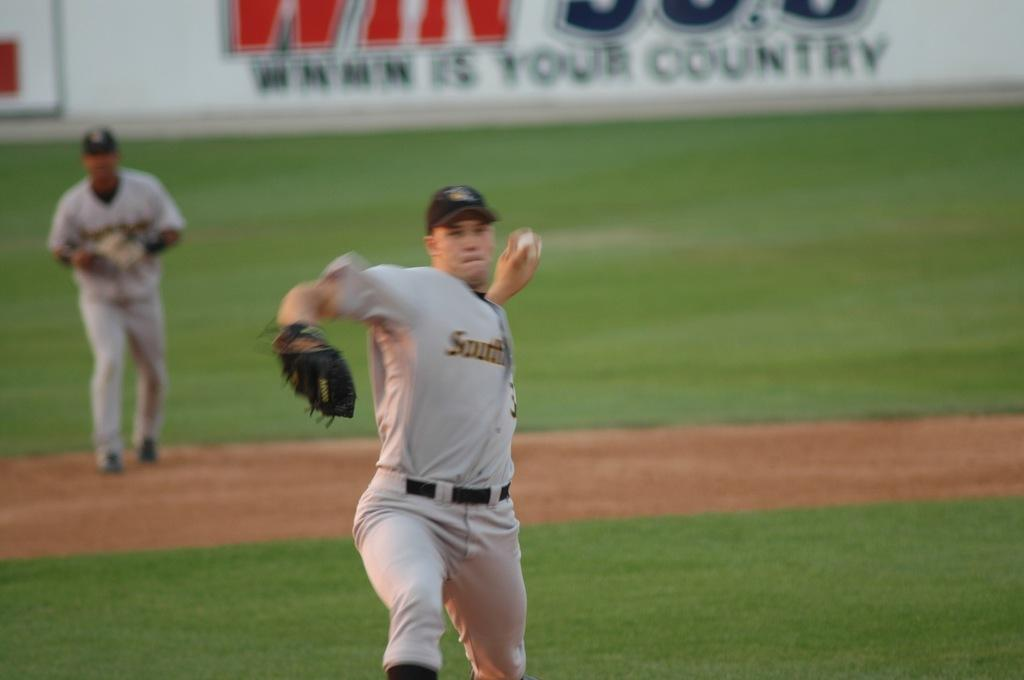How many people are in the image? There are two persons in the image. What are the two persons doing in the image? The two persons are playing baseball. What action is one of the persons taking in the image? One person is throwing a ball. What additional object can be seen in the image? There is a board with text in the image. How many spiders are crawling on the baseball bat in the image? There are no spiders present in the image. What role does the father play in the baseball game in the image? The provided facts do not mention a father or any familial relationships, so we cannot determine the role of a father in the image. 